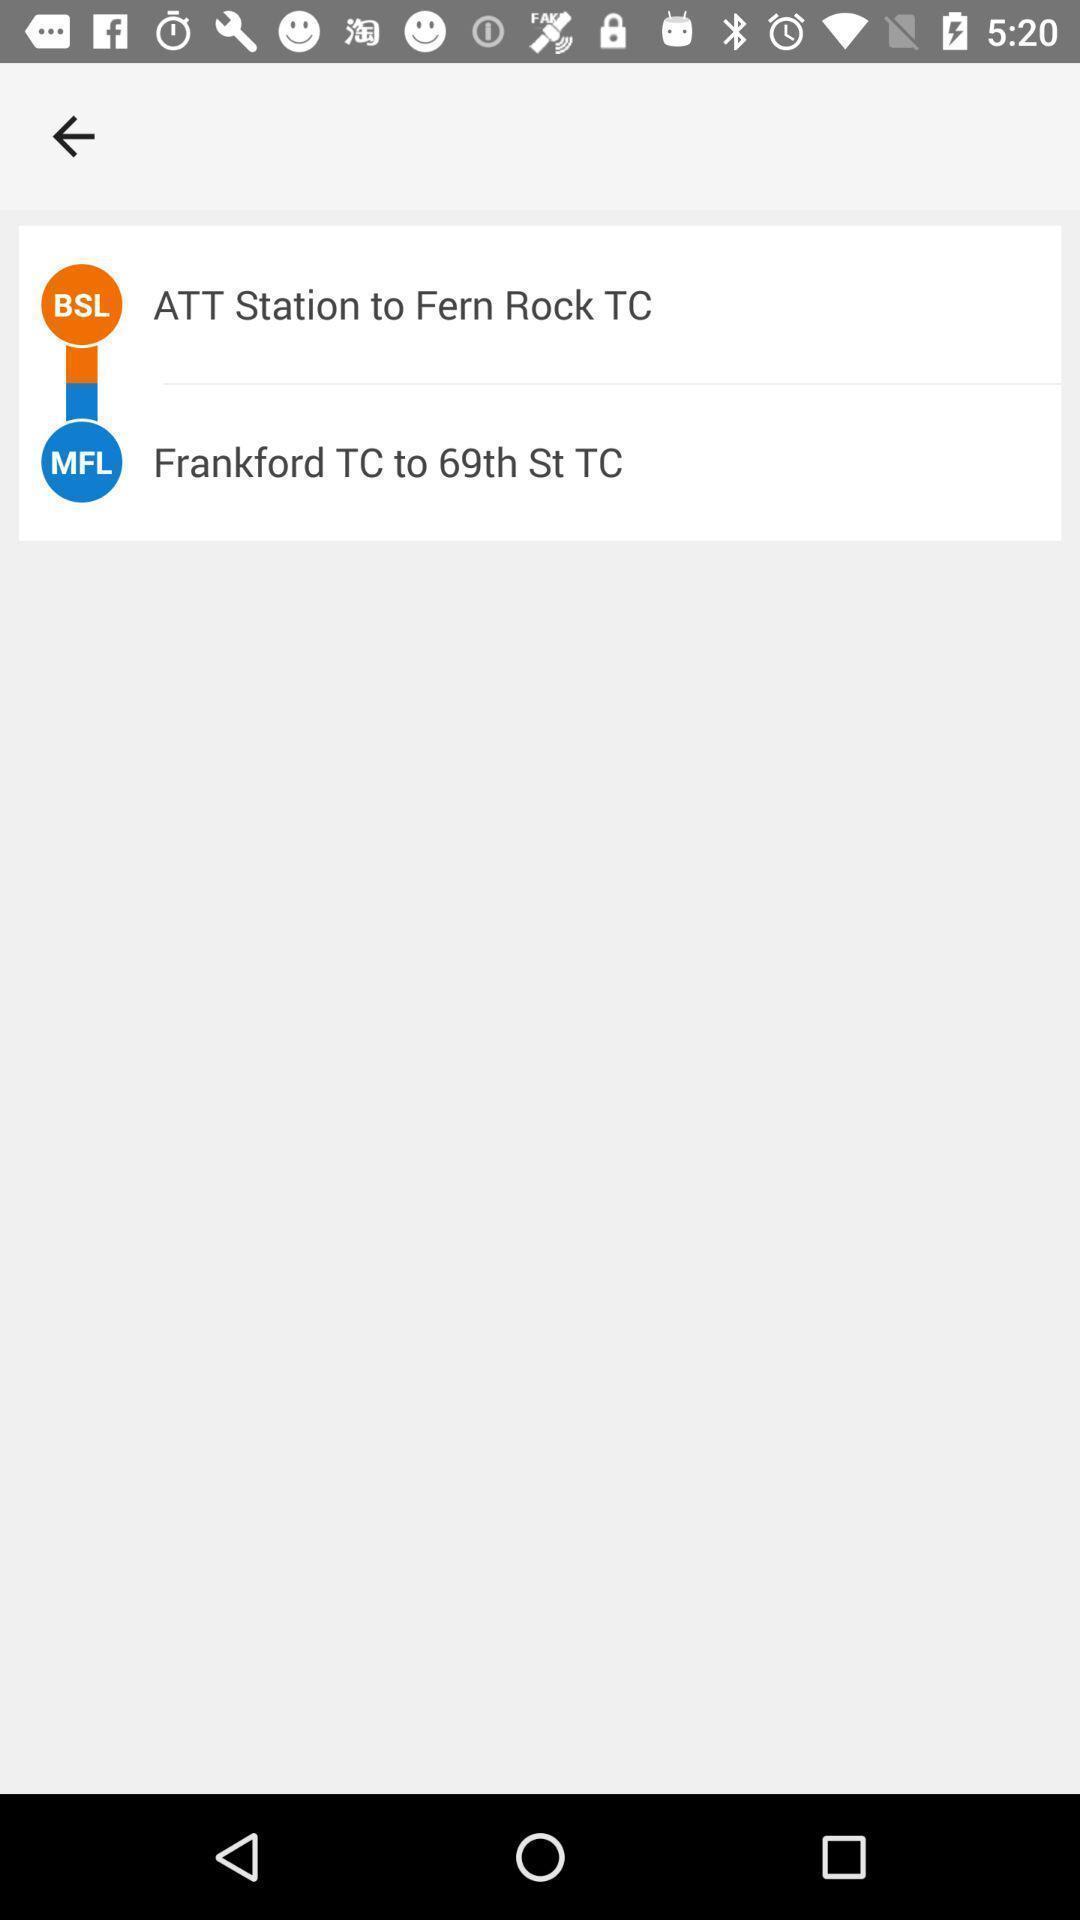What details can you identify in this image? Screen shows information about a transit app. 